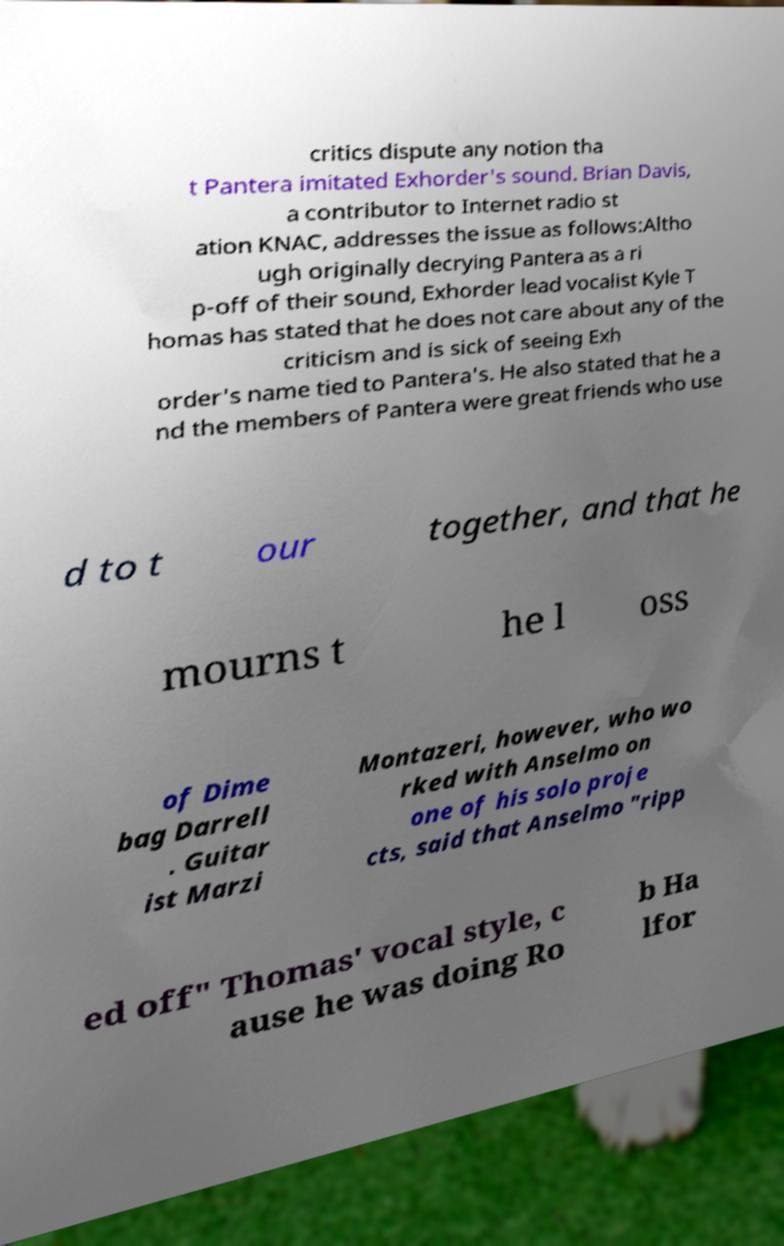What messages or text are displayed in this image? I need them in a readable, typed format. critics dispute any notion tha t Pantera imitated Exhorder's sound. Brian Davis, a contributor to Internet radio st ation KNAC, addresses the issue as follows:Altho ugh originally decrying Pantera as a ri p-off of their sound, Exhorder lead vocalist Kyle T homas has stated that he does not care about any of the criticism and is sick of seeing Exh order's name tied to Pantera's. He also stated that he a nd the members of Pantera were great friends who use d to t our together, and that he mourns t he l oss of Dime bag Darrell . Guitar ist Marzi Montazeri, however, who wo rked with Anselmo on one of his solo proje cts, said that Anselmo "ripp ed off" Thomas' vocal style, c ause he was doing Ro b Ha lfor 